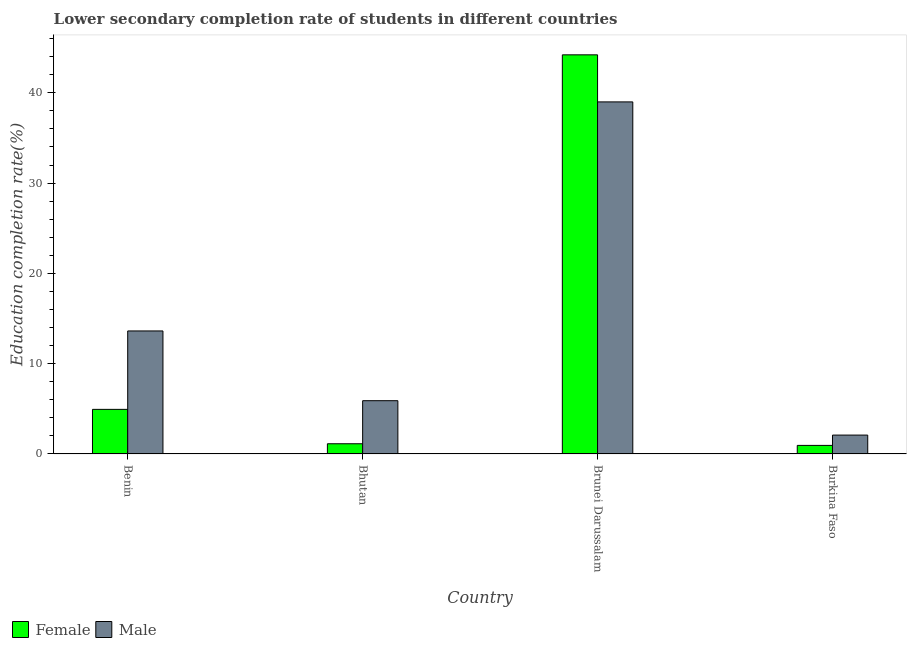How many bars are there on the 2nd tick from the left?
Your answer should be compact. 2. What is the label of the 4th group of bars from the left?
Give a very brief answer. Burkina Faso. In how many cases, is the number of bars for a given country not equal to the number of legend labels?
Give a very brief answer. 0. What is the education completion rate of male students in Brunei Darussalam?
Your answer should be very brief. 38.99. Across all countries, what is the maximum education completion rate of female students?
Give a very brief answer. 44.2. Across all countries, what is the minimum education completion rate of female students?
Provide a short and direct response. 0.95. In which country was the education completion rate of male students maximum?
Keep it short and to the point. Brunei Darussalam. In which country was the education completion rate of female students minimum?
Your answer should be compact. Burkina Faso. What is the total education completion rate of female students in the graph?
Offer a terse response. 51.22. What is the difference between the education completion rate of female students in Bhutan and that in Burkina Faso?
Offer a terse response. 0.18. What is the difference between the education completion rate of male students in Brunei Darussalam and the education completion rate of female students in Bhutan?
Your response must be concise. 37.86. What is the average education completion rate of male students per country?
Provide a succinct answer. 15.15. What is the difference between the education completion rate of male students and education completion rate of female students in Benin?
Make the answer very short. 8.68. In how many countries, is the education completion rate of male students greater than 32 %?
Give a very brief answer. 1. What is the ratio of the education completion rate of male students in Bhutan to that in Burkina Faso?
Provide a succinct answer. 2.82. What is the difference between the highest and the second highest education completion rate of male students?
Make the answer very short. 25.37. What is the difference between the highest and the lowest education completion rate of female students?
Your answer should be very brief. 43.25. In how many countries, is the education completion rate of male students greater than the average education completion rate of male students taken over all countries?
Make the answer very short. 1. How many bars are there?
Your answer should be compact. 8. How many countries are there in the graph?
Provide a succinct answer. 4. What is the difference between two consecutive major ticks on the Y-axis?
Offer a very short reply. 10. Are the values on the major ticks of Y-axis written in scientific E-notation?
Ensure brevity in your answer.  No. Does the graph contain any zero values?
Provide a succinct answer. No. Where does the legend appear in the graph?
Provide a succinct answer. Bottom left. How many legend labels are there?
Make the answer very short. 2. How are the legend labels stacked?
Offer a very short reply. Horizontal. What is the title of the graph?
Ensure brevity in your answer.  Lower secondary completion rate of students in different countries. Does "Male labourers" appear as one of the legend labels in the graph?
Provide a short and direct response. No. What is the label or title of the X-axis?
Offer a terse response. Country. What is the label or title of the Y-axis?
Keep it short and to the point. Education completion rate(%). What is the Education completion rate(%) of Female in Benin?
Provide a succinct answer. 4.94. What is the Education completion rate(%) of Male in Benin?
Give a very brief answer. 13.62. What is the Education completion rate(%) of Female in Bhutan?
Provide a short and direct response. 1.13. What is the Education completion rate(%) in Male in Bhutan?
Offer a very short reply. 5.9. What is the Education completion rate(%) of Female in Brunei Darussalam?
Make the answer very short. 44.2. What is the Education completion rate(%) in Male in Brunei Darussalam?
Your answer should be very brief. 38.99. What is the Education completion rate(%) in Female in Burkina Faso?
Ensure brevity in your answer.  0.95. What is the Education completion rate(%) of Male in Burkina Faso?
Make the answer very short. 2.09. Across all countries, what is the maximum Education completion rate(%) in Female?
Make the answer very short. 44.2. Across all countries, what is the maximum Education completion rate(%) in Male?
Your answer should be very brief. 38.99. Across all countries, what is the minimum Education completion rate(%) in Female?
Offer a terse response. 0.95. Across all countries, what is the minimum Education completion rate(%) in Male?
Give a very brief answer. 2.09. What is the total Education completion rate(%) of Female in the graph?
Your answer should be compact. 51.22. What is the total Education completion rate(%) in Male in the graph?
Offer a very short reply. 60.61. What is the difference between the Education completion rate(%) in Female in Benin and that in Bhutan?
Give a very brief answer. 3.81. What is the difference between the Education completion rate(%) in Male in Benin and that in Bhutan?
Ensure brevity in your answer.  7.72. What is the difference between the Education completion rate(%) in Female in Benin and that in Brunei Darussalam?
Make the answer very short. -39.26. What is the difference between the Education completion rate(%) in Male in Benin and that in Brunei Darussalam?
Ensure brevity in your answer.  -25.37. What is the difference between the Education completion rate(%) in Female in Benin and that in Burkina Faso?
Make the answer very short. 3.99. What is the difference between the Education completion rate(%) of Male in Benin and that in Burkina Faso?
Offer a terse response. 11.53. What is the difference between the Education completion rate(%) in Female in Bhutan and that in Brunei Darussalam?
Your answer should be very brief. -43.07. What is the difference between the Education completion rate(%) of Male in Bhutan and that in Brunei Darussalam?
Give a very brief answer. -33.09. What is the difference between the Education completion rate(%) in Female in Bhutan and that in Burkina Faso?
Offer a terse response. 0.18. What is the difference between the Education completion rate(%) in Male in Bhutan and that in Burkina Faso?
Your response must be concise. 3.81. What is the difference between the Education completion rate(%) in Female in Brunei Darussalam and that in Burkina Faso?
Your answer should be very brief. 43.25. What is the difference between the Education completion rate(%) in Male in Brunei Darussalam and that in Burkina Faso?
Offer a very short reply. 36.9. What is the difference between the Education completion rate(%) of Female in Benin and the Education completion rate(%) of Male in Bhutan?
Provide a short and direct response. -0.96. What is the difference between the Education completion rate(%) in Female in Benin and the Education completion rate(%) in Male in Brunei Darussalam?
Your answer should be compact. -34.05. What is the difference between the Education completion rate(%) of Female in Benin and the Education completion rate(%) of Male in Burkina Faso?
Ensure brevity in your answer.  2.85. What is the difference between the Education completion rate(%) of Female in Bhutan and the Education completion rate(%) of Male in Brunei Darussalam?
Offer a very short reply. -37.86. What is the difference between the Education completion rate(%) of Female in Bhutan and the Education completion rate(%) of Male in Burkina Faso?
Offer a very short reply. -0.96. What is the difference between the Education completion rate(%) in Female in Brunei Darussalam and the Education completion rate(%) in Male in Burkina Faso?
Your answer should be compact. 42.11. What is the average Education completion rate(%) in Female per country?
Provide a short and direct response. 12.81. What is the average Education completion rate(%) in Male per country?
Your answer should be compact. 15.15. What is the difference between the Education completion rate(%) of Female and Education completion rate(%) of Male in Benin?
Your response must be concise. -8.68. What is the difference between the Education completion rate(%) in Female and Education completion rate(%) in Male in Bhutan?
Provide a succinct answer. -4.77. What is the difference between the Education completion rate(%) of Female and Education completion rate(%) of Male in Brunei Darussalam?
Your response must be concise. 5.21. What is the difference between the Education completion rate(%) in Female and Education completion rate(%) in Male in Burkina Faso?
Keep it short and to the point. -1.14. What is the ratio of the Education completion rate(%) of Female in Benin to that in Bhutan?
Give a very brief answer. 4.37. What is the ratio of the Education completion rate(%) of Male in Benin to that in Bhutan?
Keep it short and to the point. 2.31. What is the ratio of the Education completion rate(%) in Female in Benin to that in Brunei Darussalam?
Make the answer very short. 0.11. What is the ratio of the Education completion rate(%) in Male in Benin to that in Brunei Darussalam?
Ensure brevity in your answer.  0.35. What is the ratio of the Education completion rate(%) in Female in Benin to that in Burkina Faso?
Give a very brief answer. 5.21. What is the ratio of the Education completion rate(%) in Male in Benin to that in Burkina Faso?
Give a very brief answer. 6.52. What is the ratio of the Education completion rate(%) in Female in Bhutan to that in Brunei Darussalam?
Your answer should be compact. 0.03. What is the ratio of the Education completion rate(%) in Male in Bhutan to that in Brunei Darussalam?
Provide a succinct answer. 0.15. What is the ratio of the Education completion rate(%) of Female in Bhutan to that in Burkina Faso?
Offer a very short reply. 1.19. What is the ratio of the Education completion rate(%) in Male in Bhutan to that in Burkina Faso?
Your response must be concise. 2.82. What is the ratio of the Education completion rate(%) of Female in Brunei Darussalam to that in Burkina Faso?
Give a very brief answer. 46.59. What is the ratio of the Education completion rate(%) of Male in Brunei Darussalam to that in Burkina Faso?
Make the answer very short. 18.64. What is the difference between the highest and the second highest Education completion rate(%) in Female?
Offer a terse response. 39.26. What is the difference between the highest and the second highest Education completion rate(%) in Male?
Ensure brevity in your answer.  25.37. What is the difference between the highest and the lowest Education completion rate(%) of Female?
Ensure brevity in your answer.  43.25. What is the difference between the highest and the lowest Education completion rate(%) in Male?
Offer a very short reply. 36.9. 